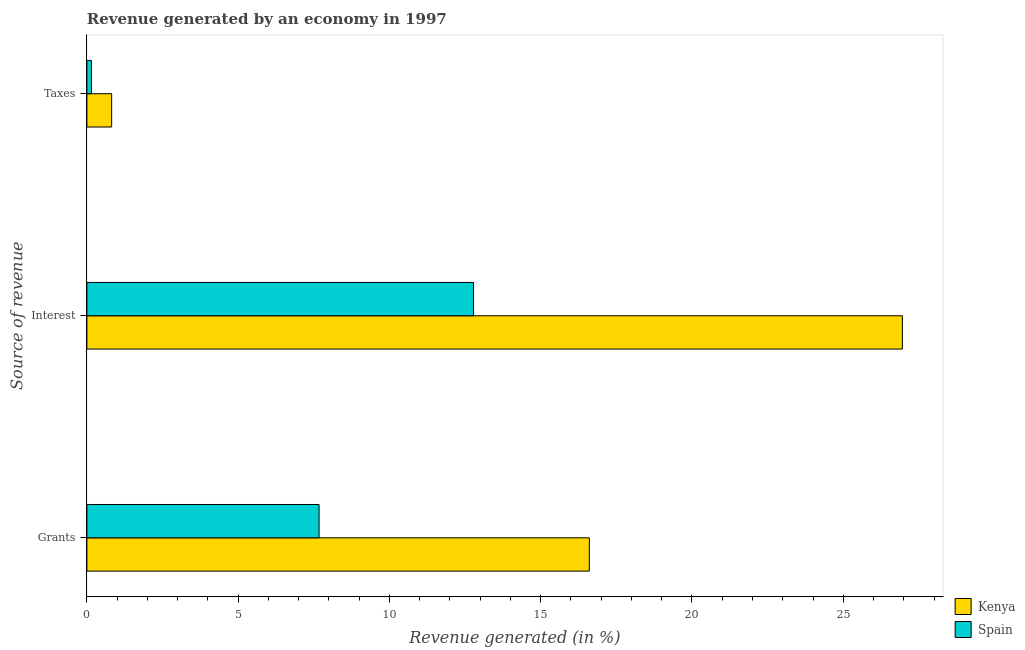How many different coloured bars are there?
Ensure brevity in your answer.  2. Are the number of bars per tick equal to the number of legend labels?
Provide a succinct answer. Yes. What is the label of the 1st group of bars from the top?
Give a very brief answer. Taxes. What is the percentage of revenue generated by grants in Spain?
Provide a succinct answer. 7.67. Across all countries, what is the maximum percentage of revenue generated by interest?
Offer a terse response. 26.95. Across all countries, what is the minimum percentage of revenue generated by taxes?
Your response must be concise. 0.15. In which country was the percentage of revenue generated by grants maximum?
Give a very brief answer. Kenya. What is the total percentage of revenue generated by interest in the graph?
Offer a very short reply. 39.73. What is the difference between the percentage of revenue generated by grants in Kenya and that in Spain?
Keep it short and to the point. 8.93. What is the difference between the percentage of revenue generated by grants in Spain and the percentage of revenue generated by interest in Kenya?
Your answer should be very brief. -19.28. What is the average percentage of revenue generated by interest per country?
Provide a short and direct response. 19.87. What is the difference between the percentage of revenue generated by taxes and percentage of revenue generated by interest in Spain?
Give a very brief answer. -12.63. In how many countries, is the percentage of revenue generated by grants greater than 22 %?
Your answer should be very brief. 0. What is the ratio of the percentage of revenue generated by grants in Spain to that in Kenya?
Your answer should be compact. 0.46. What is the difference between the highest and the second highest percentage of revenue generated by taxes?
Your answer should be compact. 0.67. What is the difference between the highest and the lowest percentage of revenue generated by grants?
Give a very brief answer. 8.93. What does the 2nd bar from the top in Grants represents?
Offer a very short reply. Kenya. What does the 1st bar from the bottom in Interest represents?
Offer a terse response. Kenya. Are the values on the major ticks of X-axis written in scientific E-notation?
Give a very brief answer. No. Does the graph contain any zero values?
Make the answer very short. No. Does the graph contain grids?
Your answer should be very brief. No. What is the title of the graph?
Ensure brevity in your answer.  Revenue generated by an economy in 1997. What is the label or title of the X-axis?
Provide a short and direct response. Revenue generated (in %). What is the label or title of the Y-axis?
Provide a succinct answer. Source of revenue. What is the Revenue generated (in %) in Kenya in Grants?
Your answer should be very brief. 16.61. What is the Revenue generated (in %) of Spain in Grants?
Your answer should be very brief. 7.67. What is the Revenue generated (in %) of Kenya in Interest?
Make the answer very short. 26.95. What is the Revenue generated (in %) in Spain in Interest?
Provide a succinct answer. 12.78. What is the Revenue generated (in %) in Kenya in Taxes?
Provide a succinct answer. 0.82. What is the Revenue generated (in %) in Spain in Taxes?
Ensure brevity in your answer.  0.15. Across all Source of revenue, what is the maximum Revenue generated (in %) in Kenya?
Keep it short and to the point. 26.95. Across all Source of revenue, what is the maximum Revenue generated (in %) in Spain?
Give a very brief answer. 12.78. Across all Source of revenue, what is the minimum Revenue generated (in %) in Kenya?
Make the answer very short. 0.82. Across all Source of revenue, what is the minimum Revenue generated (in %) of Spain?
Keep it short and to the point. 0.15. What is the total Revenue generated (in %) in Kenya in the graph?
Offer a very short reply. 44.38. What is the total Revenue generated (in %) of Spain in the graph?
Offer a very short reply. 20.61. What is the difference between the Revenue generated (in %) of Kenya in Grants and that in Interest?
Make the answer very short. -10.35. What is the difference between the Revenue generated (in %) of Spain in Grants and that in Interest?
Offer a very short reply. -5.11. What is the difference between the Revenue generated (in %) of Kenya in Grants and that in Taxes?
Provide a short and direct response. 15.79. What is the difference between the Revenue generated (in %) of Spain in Grants and that in Taxes?
Keep it short and to the point. 7.52. What is the difference between the Revenue generated (in %) in Kenya in Interest and that in Taxes?
Give a very brief answer. 26.13. What is the difference between the Revenue generated (in %) of Spain in Interest and that in Taxes?
Make the answer very short. 12.63. What is the difference between the Revenue generated (in %) in Kenya in Grants and the Revenue generated (in %) in Spain in Interest?
Provide a short and direct response. 3.83. What is the difference between the Revenue generated (in %) in Kenya in Grants and the Revenue generated (in %) in Spain in Taxes?
Offer a terse response. 16.46. What is the difference between the Revenue generated (in %) of Kenya in Interest and the Revenue generated (in %) of Spain in Taxes?
Your answer should be very brief. 26.8. What is the average Revenue generated (in %) in Kenya per Source of revenue?
Offer a terse response. 14.79. What is the average Revenue generated (in %) of Spain per Source of revenue?
Your answer should be compact. 6.87. What is the difference between the Revenue generated (in %) in Kenya and Revenue generated (in %) in Spain in Grants?
Give a very brief answer. 8.93. What is the difference between the Revenue generated (in %) of Kenya and Revenue generated (in %) of Spain in Interest?
Keep it short and to the point. 14.17. What is the difference between the Revenue generated (in %) of Kenya and Revenue generated (in %) of Spain in Taxes?
Your answer should be compact. 0.67. What is the ratio of the Revenue generated (in %) in Kenya in Grants to that in Interest?
Give a very brief answer. 0.62. What is the ratio of the Revenue generated (in %) in Spain in Grants to that in Interest?
Ensure brevity in your answer.  0.6. What is the ratio of the Revenue generated (in %) of Kenya in Grants to that in Taxes?
Make the answer very short. 20.28. What is the ratio of the Revenue generated (in %) of Spain in Grants to that in Taxes?
Offer a very short reply. 50.82. What is the ratio of the Revenue generated (in %) in Kenya in Interest to that in Taxes?
Your response must be concise. 32.91. What is the ratio of the Revenue generated (in %) of Spain in Interest to that in Taxes?
Your answer should be compact. 84.63. What is the difference between the highest and the second highest Revenue generated (in %) in Kenya?
Your response must be concise. 10.35. What is the difference between the highest and the second highest Revenue generated (in %) of Spain?
Ensure brevity in your answer.  5.11. What is the difference between the highest and the lowest Revenue generated (in %) in Kenya?
Your response must be concise. 26.13. What is the difference between the highest and the lowest Revenue generated (in %) of Spain?
Your response must be concise. 12.63. 